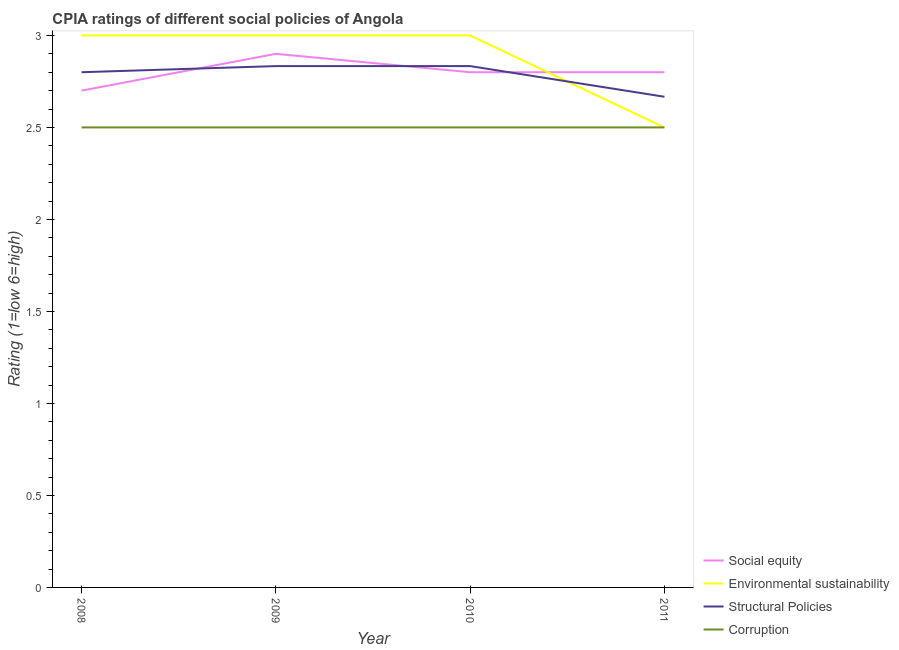How many different coloured lines are there?
Make the answer very short. 4. Is the number of lines equal to the number of legend labels?
Make the answer very short. Yes. Across all years, what is the maximum cpia rating of social equity?
Your answer should be very brief. 2.9. Across all years, what is the minimum cpia rating of structural policies?
Ensure brevity in your answer.  2.67. In which year was the cpia rating of environmental sustainability maximum?
Keep it short and to the point. 2008. What is the total cpia rating of corruption in the graph?
Offer a terse response. 10. What is the difference between the cpia rating of social equity in 2009 and that in 2011?
Give a very brief answer. 0.1. What is the difference between the cpia rating of social equity in 2011 and the cpia rating of corruption in 2008?
Provide a succinct answer. 0.3. What is the average cpia rating of social equity per year?
Offer a very short reply. 2.8. In the year 2010, what is the difference between the cpia rating of corruption and cpia rating of social equity?
Your response must be concise. -0.3. What is the ratio of the cpia rating of environmental sustainability in 2008 to that in 2011?
Provide a succinct answer. 1.2. Is the cpia rating of corruption in 2010 less than that in 2011?
Provide a short and direct response. No. In how many years, is the cpia rating of structural policies greater than the average cpia rating of structural policies taken over all years?
Provide a short and direct response. 3. Is the sum of the cpia rating of structural policies in 2008 and 2010 greater than the maximum cpia rating of social equity across all years?
Offer a very short reply. Yes. Is it the case that in every year, the sum of the cpia rating of structural policies and cpia rating of social equity is greater than the sum of cpia rating of environmental sustainability and cpia rating of corruption?
Give a very brief answer. No. Does the cpia rating of corruption monotonically increase over the years?
Offer a terse response. No. What is the difference between two consecutive major ticks on the Y-axis?
Provide a short and direct response. 0.5. Are the values on the major ticks of Y-axis written in scientific E-notation?
Offer a terse response. No. How many legend labels are there?
Make the answer very short. 4. What is the title of the graph?
Keep it short and to the point. CPIA ratings of different social policies of Angola. What is the Rating (1=low 6=high) in Environmental sustainability in 2008?
Your response must be concise. 3. What is the Rating (1=low 6=high) of Corruption in 2008?
Your answer should be very brief. 2.5. What is the Rating (1=low 6=high) of Structural Policies in 2009?
Give a very brief answer. 2.83. What is the Rating (1=low 6=high) of Social equity in 2010?
Keep it short and to the point. 2.8. What is the Rating (1=low 6=high) of Structural Policies in 2010?
Make the answer very short. 2.83. What is the Rating (1=low 6=high) of Structural Policies in 2011?
Provide a succinct answer. 2.67. Across all years, what is the maximum Rating (1=low 6=high) in Social equity?
Your response must be concise. 2.9. Across all years, what is the maximum Rating (1=low 6=high) of Environmental sustainability?
Ensure brevity in your answer.  3. Across all years, what is the maximum Rating (1=low 6=high) of Structural Policies?
Provide a short and direct response. 2.83. Across all years, what is the minimum Rating (1=low 6=high) in Environmental sustainability?
Your answer should be compact. 2.5. Across all years, what is the minimum Rating (1=low 6=high) in Structural Policies?
Keep it short and to the point. 2.67. What is the total Rating (1=low 6=high) of Structural Policies in the graph?
Offer a terse response. 11.13. What is the total Rating (1=low 6=high) in Corruption in the graph?
Provide a succinct answer. 10. What is the difference between the Rating (1=low 6=high) of Social equity in 2008 and that in 2009?
Keep it short and to the point. -0.2. What is the difference between the Rating (1=low 6=high) in Structural Policies in 2008 and that in 2009?
Make the answer very short. -0.03. What is the difference between the Rating (1=low 6=high) of Corruption in 2008 and that in 2009?
Give a very brief answer. 0. What is the difference between the Rating (1=low 6=high) in Environmental sustainability in 2008 and that in 2010?
Give a very brief answer. 0. What is the difference between the Rating (1=low 6=high) of Structural Policies in 2008 and that in 2010?
Offer a terse response. -0.03. What is the difference between the Rating (1=low 6=high) in Environmental sustainability in 2008 and that in 2011?
Your answer should be very brief. 0.5. What is the difference between the Rating (1=low 6=high) of Structural Policies in 2008 and that in 2011?
Provide a succinct answer. 0.13. What is the difference between the Rating (1=low 6=high) in Corruption in 2009 and that in 2011?
Give a very brief answer. 0. What is the difference between the Rating (1=low 6=high) of Social equity in 2008 and the Rating (1=low 6=high) of Structural Policies in 2009?
Your response must be concise. -0.13. What is the difference between the Rating (1=low 6=high) in Environmental sustainability in 2008 and the Rating (1=low 6=high) in Structural Policies in 2009?
Make the answer very short. 0.17. What is the difference between the Rating (1=low 6=high) of Environmental sustainability in 2008 and the Rating (1=low 6=high) of Corruption in 2009?
Your response must be concise. 0.5. What is the difference between the Rating (1=low 6=high) of Social equity in 2008 and the Rating (1=low 6=high) of Environmental sustainability in 2010?
Provide a short and direct response. -0.3. What is the difference between the Rating (1=low 6=high) of Social equity in 2008 and the Rating (1=low 6=high) of Structural Policies in 2010?
Your answer should be very brief. -0.13. What is the difference between the Rating (1=low 6=high) in Environmental sustainability in 2008 and the Rating (1=low 6=high) in Structural Policies in 2010?
Offer a very short reply. 0.17. What is the difference between the Rating (1=low 6=high) in Environmental sustainability in 2008 and the Rating (1=low 6=high) in Corruption in 2010?
Offer a very short reply. 0.5. What is the difference between the Rating (1=low 6=high) in Structural Policies in 2008 and the Rating (1=low 6=high) in Corruption in 2010?
Give a very brief answer. 0.3. What is the difference between the Rating (1=low 6=high) in Social equity in 2008 and the Rating (1=low 6=high) in Structural Policies in 2011?
Make the answer very short. 0.03. What is the difference between the Rating (1=low 6=high) of Social equity in 2008 and the Rating (1=low 6=high) of Corruption in 2011?
Your answer should be compact. 0.2. What is the difference between the Rating (1=low 6=high) of Environmental sustainability in 2008 and the Rating (1=low 6=high) of Structural Policies in 2011?
Keep it short and to the point. 0.33. What is the difference between the Rating (1=low 6=high) in Environmental sustainability in 2008 and the Rating (1=low 6=high) in Corruption in 2011?
Provide a succinct answer. 0.5. What is the difference between the Rating (1=low 6=high) in Social equity in 2009 and the Rating (1=low 6=high) in Structural Policies in 2010?
Offer a terse response. 0.07. What is the difference between the Rating (1=low 6=high) in Social equity in 2009 and the Rating (1=low 6=high) in Corruption in 2010?
Your answer should be compact. 0.4. What is the difference between the Rating (1=low 6=high) in Environmental sustainability in 2009 and the Rating (1=low 6=high) in Structural Policies in 2010?
Your response must be concise. 0.17. What is the difference between the Rating (1=low 6=high) of Social equity in 2009 and the Rating (1=low 6=high) of Structural Policies in 2011?
Provide a succinct answer. 0.23. What is the difference between the Rating (1=low 6=high) of Social equity in 2009 and the Rating (1=low 6=high) of Corruption in 2011?
Your answer should be very brief. 0.4. What is the difference between the Rating (1=low 6=high) in Environmental sustainability in 2009 and the Rating (1=low 6=high) in Structural Policies in 2011?
Provide a succinct answer. 0.33. What is the difference between the Rating (1=low 6=high) in Social equity in 2010 and the Rating (1=low 6=high) in Structural Policies in 2011?
Ensure brevity in your answer.  0.13. What is the difference between the Rating (1=low 6=high) in Social equity in 2010 and the Rating (1=low 6=high) in Corruption in 2011?
Your answer should be compact. 0.3. What is the difference between the Rating (1=low 6=high) of Environmental sustainability in 2010 and the Rating (1=low 6=high) of Corruption in 2011?
Your response must be concise. 0.5. What is the average Rating (1=low 6=high) in Social equity per year?
Offer a very short reply. 2.8. What is the average Rating (1=low 6=high) of Environmental sustainability per year?
Ensure brevity in your answer.  2.88. What is the average Rating (1=low 6=high) in Structural Policies per year?
Your answer should be very brief. 2.78. In the year 2008, what is the difference between the Rating (1=low 6=high) in Social equity and Rating (1=low 6=high) in Environmental sustainability?
Give a very brief answer. -0.3. In the year 2009, what is the difference between the Rating (1=low 6=high) in Social equity and Rating (1=low 6=high) in Structural Policies?
Give a very brief answer. 0.07. In the year 2009, what is the difference between the Rating (1=low 6=high) of Environmental sustainability and Rating (1=low 6=high) of Corruption?
Your answer should be very brief. 0.5. In the year 2009, what is the difference between the Rating (1=low 6=high) in Structural Policies and Rating (1=low 6=high) in Corruption?
Provide a short and direct response. 0.33. In the year 2010, what is the difference between the Rating (1=low 6=high) of Social equity and Rating (1=low 6=high) of Structural Policies?
Offer a terse response. -0.03. In the year 2010, what is the difference between the Rating (1=low 6=high) of Environmental sustainability and Rating (1=low 6=high) of Corruption?
Ensure brevity in your answer.  0.5. In the year 2011, what is the difference between the Rating (1=low 6=high) of Social equity and Rating (1=low 6=high) of Environmental sustainability?
Make the answer very short. 0.3. In the year 2011, what is the difference between the Rating (1=low 6=high) of Social equity and Rating (1=low 6=high) of Structural Policies?
Your answer should be compact. 0.13. In the year 2011, what is the difference between the Rating (1=low 6=high) of Social equity and Rating (1=low 6=high) of Corruption?
Give a very brief answer. 0.3. In the year 2011, what is the difference between the Rating (1=low 6=high) in Environmental sustainability and Rating (1=low 6=high) in Structural Policies?
Provide a succinct answer. -0.17. What is the ratio of the Rating (1=low 6=high) in Social equity in 2008 to that in 2009?
Provide a succinct answer. 0.93. What is the ratio of the Rating (1=low 6=high) in Structural Policies in 2008 to that in 2009?
Your answer should be very brief. 0.99. What is the ratio of the Rating (1=low 6=high) in Corruption in 2008 to that in 2009?
Make the answer very short. 1. What is the ratio of the Rating (1=low 6=high) of Structural Policies in 2008 to that in 2010?
Your answer should be compact. 0.99. What is the ratio of the Rating (1=low 6=high) of Social equity in 2008 to that in 2011?
Offer a terse response. 0.96. What is the ratio of the Rating (1=low 6=high) in Environmental sustainability in 2008 to that in 2011?
Make the answer very short. 1.2. What is the ratio of the Rating (1=low 6=high) of Corruption in 2008 to that in 2011?
Your answer should be compact. 1. What is the ratio of the Rating (1=low 6=high) of Social equity in 2009 to that in 2010?
Keep it short and to the point. 1.04. What is the ratio of the Rating (1=low 6=high) in Structural Policies in 2009 to that in 2010?
Ensure brevity in your answer.  1. What is the ratio of the Rating (1=low 6=high) in Corruption in 2009 to that in 2010?
Make the answer very short. 1. What is the ratio of the Rating (1=low 6=high) in Social equity in 2009 to that in 2011?
Provide a succinct answer. 1.04. What is the ratio of the Rating (1=low 6=high) of Environmental sustainability in 2009 to that in 2011?
Give a very brief answer. 1.2. What is the ratio of the Rating (1=low 6=high) in Structural Policies in 2009 to that in 2011?
Your answer should be very brief. 1.06. What is the ratio of the Rating (1=low 6=high) of Environmental sustainability in 2010 to that in 2011?
Ensure brevity in your answer.  1.2. What is the difference between the highest and the lowest Rating (1=low 6=high) of Structural Policies?
Offer a terse response. 0.17. What is the difference between the highest and the lowest Rating (1=low 6=high) in Corruption?
Provide a short and direct response. 0. 